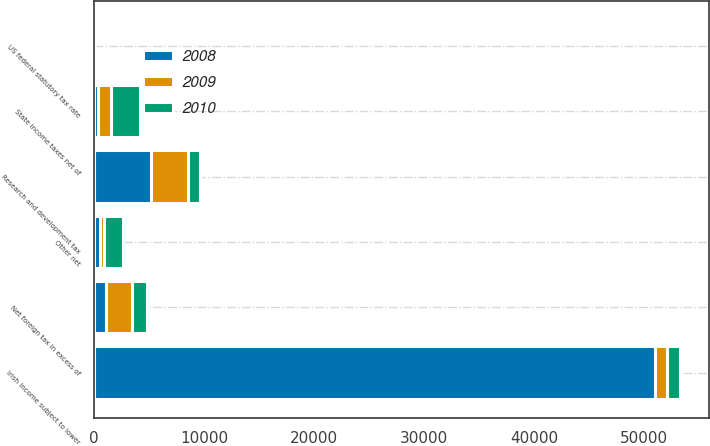Convert chart. <chart><loc_0><loc_0><loc_500><loc_500><stacked_bar_chart><ecel><fcel>US federal statutory tax rate<fcel>Irish income subject to lower<fcel>State income taxes net of<fcel>Research and development tax<fcel>Net foreign tax in excess of<fcel>Other net<nl><fcel>2010<fcel>35<fcel>1136.5<fcel>2622<fcel>1045<fcel>1315<fcel>1706<nl><fcel>2008<fcel>35<fcel>50972<fcel>406<fcel>5153<fcel>1123<fcel>527<nl><fcel>2009<fcel>35<fcel>1136.5<fcel>1150<fcel>3401<fcel>2350<fcel>422<nl></chart> 